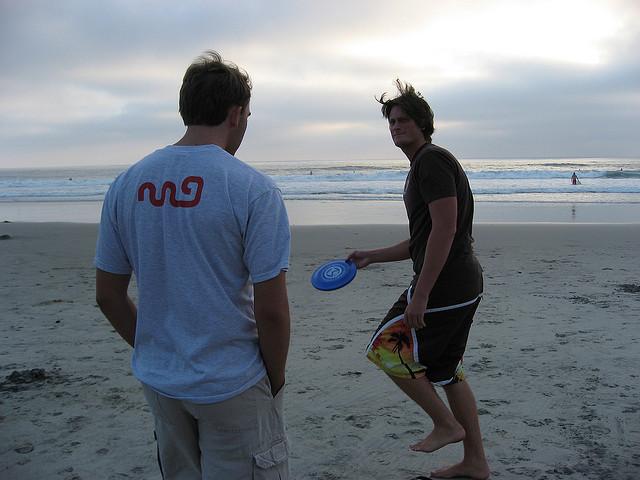Who is barefooted?
Answer briefly. Man. What is the man holding?
Write a very short answer. Frisbee. What type of clouds are visible in this photo?
Quick response, please. Rain. Is the man skating with shoes?
Concise answer only. No. How many people are at the beach?
Concise answer only. 2. Is it windy?
Be succinct. Yes. What is under the man's feet?
Short answer required. Sand. Did they just come back from surfing?
Give a very brief answer. No. What are these guys doing?
Keep it brief. Playing frisbee. 